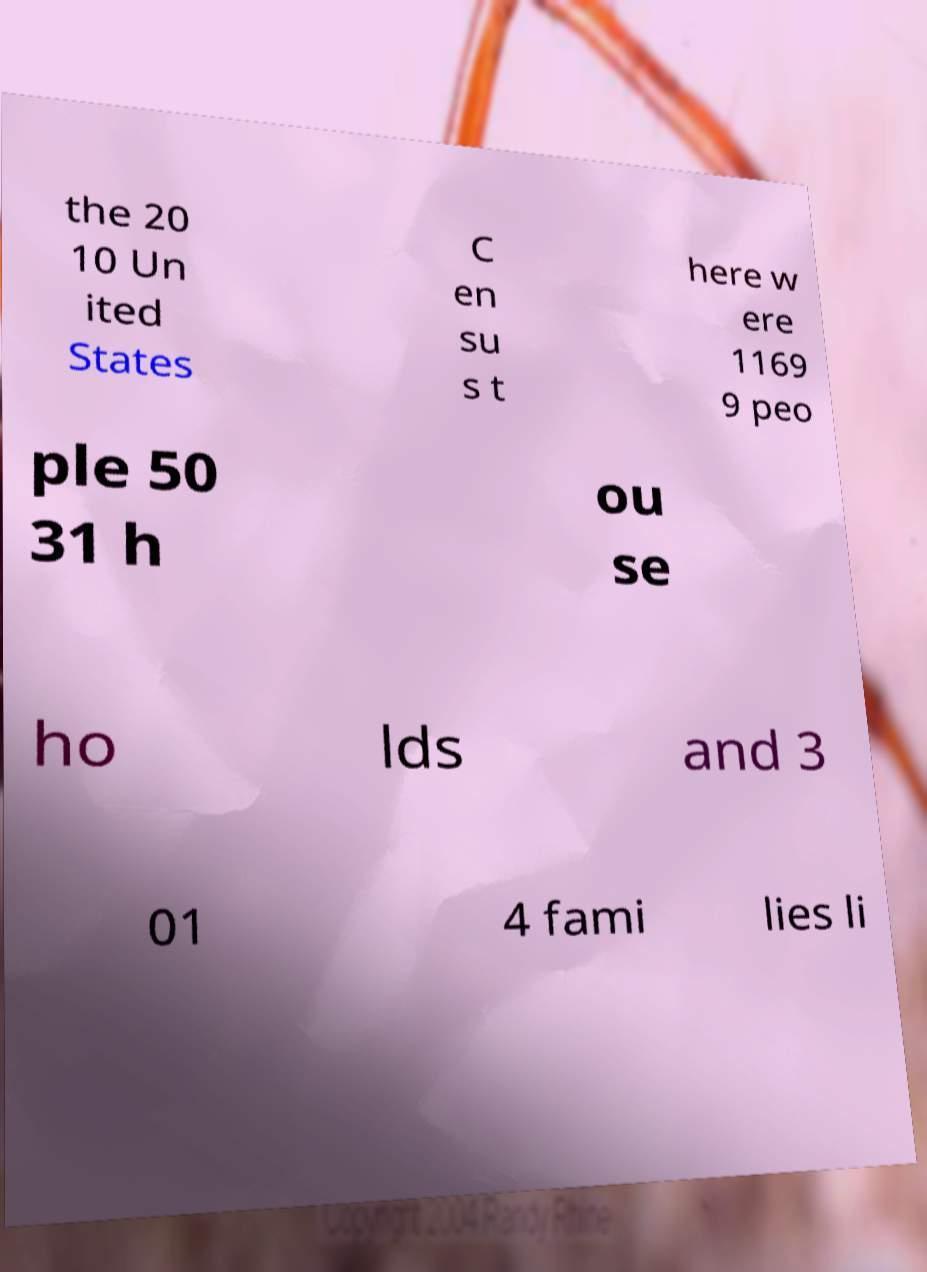For documentation purposes, I need the text within this image transcribed. Could you provide that? the 20 10 Un ited States C en su s t here w ere 1169 9 peo ple 50 31 h ou se ho lds and 3 01 4 fami lies li 